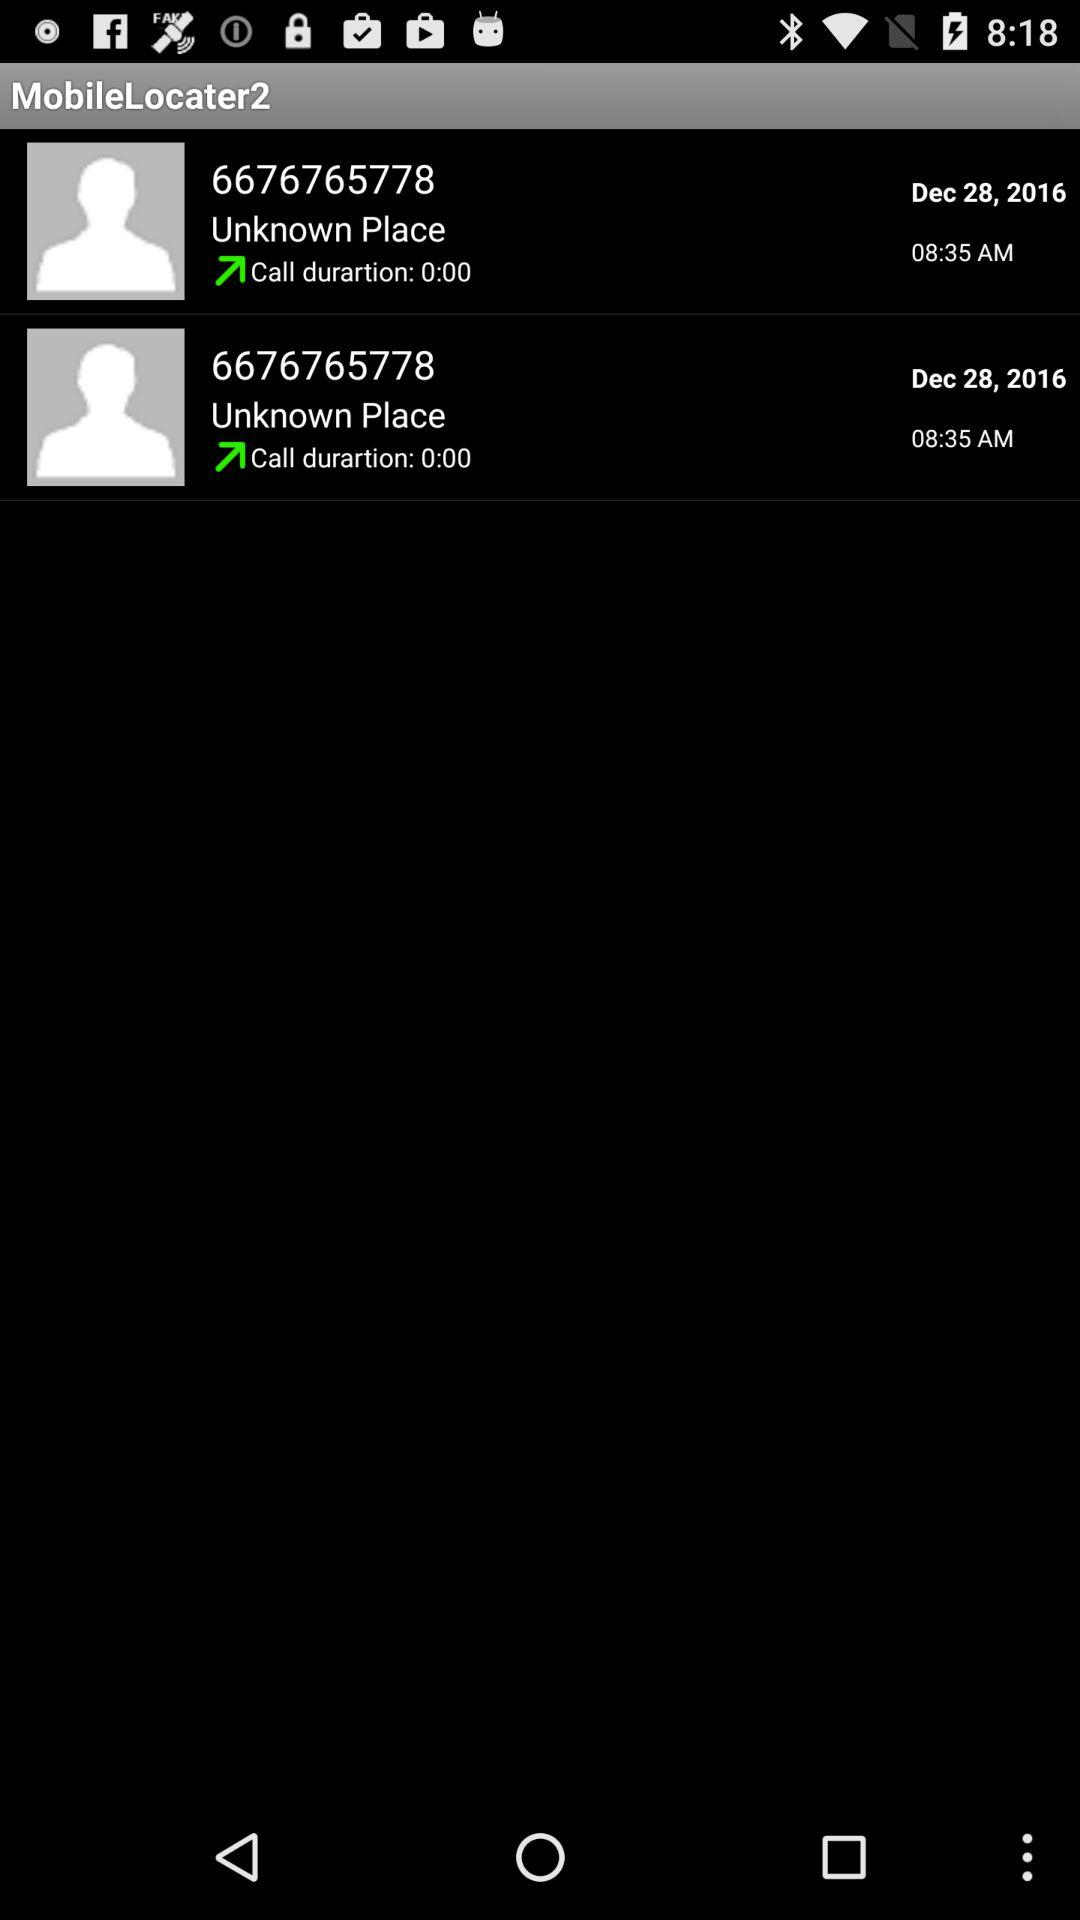Who is this application powered by?
When the provided information is insufficient, respond with <no answer>. <no answer> 